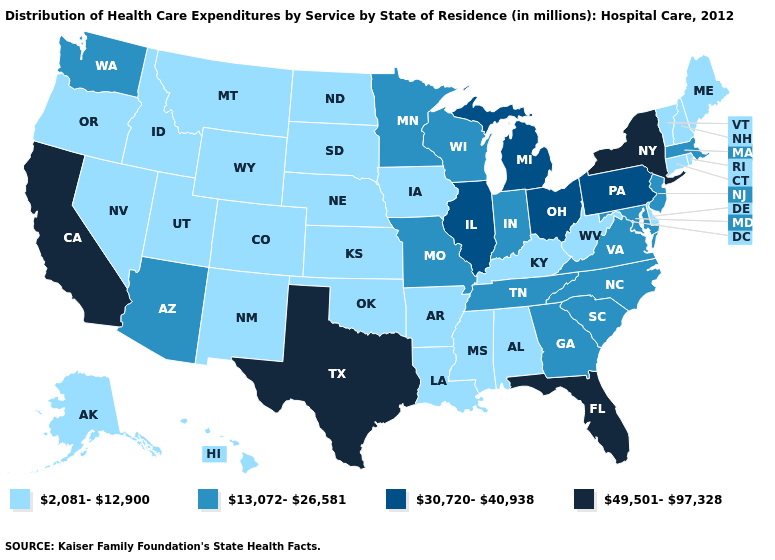What is the highest value in the West ?
Short answer required. 49,501-97,328. Does Minnesota have a lower value than Florida?
Quick response, please. Yes. What is the lowest value in the South?
Keep it brief. 2,081-12,900. Does Virginia have the highest value in the South?
Give a very brief answer. No. Name the states that have a value in the range 30,720-40,938?
Answer briefly. Illinois, Michigan, Ohio, Pennsylvania. Which states have the highest value in the USA?
Concise answer only. California, Florida, New York, Texas. What is the lowest value in the USA?
Write a very short answer. 2,081-12,900. Name the states that have a value in the range 49,501-97,328?
Be succinct. California, Florida, New York, Texas. Which states have the highest value in the USA?
Be succinct. California, Florida, New York, Texas. Does North Carolina have a lower value than Ohio?
Give a very brief answer. Yes. What is the value of Maine?
Concise answer only. 2,081-12,900. Among the states that border Idaho , which have the lowest value?
Give a very brief answer. Montana, Nevada, Oregon, Utah, Wyoming. What is the value of Delaware?
Keep it brief. 2,081-12,900. What is the lowest value in the USA?
Write a very short answer. 2,081-12,900. Does Alaska have a higher value than North Carolina?
Answer briefly. No. 